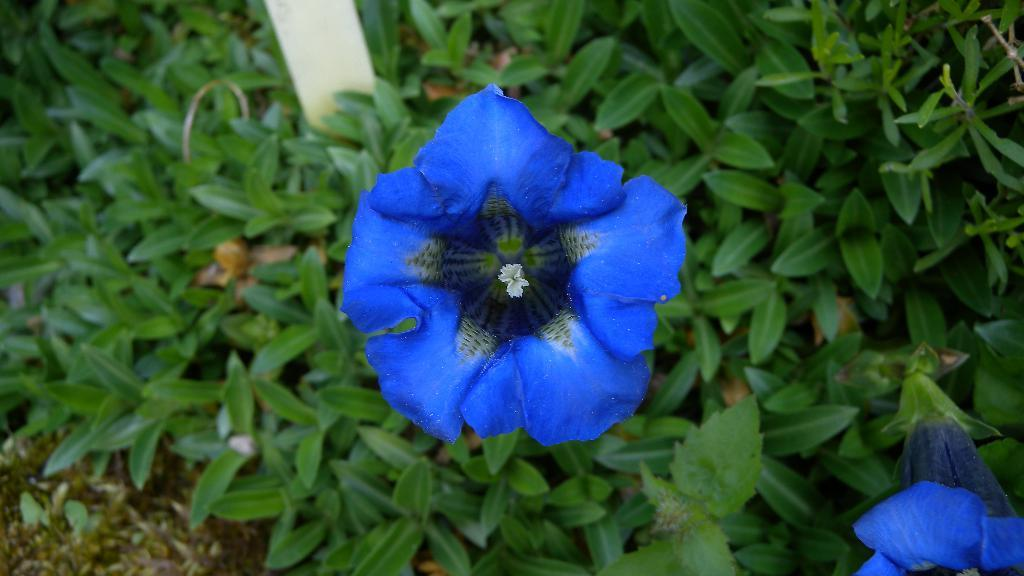What type of flower is in the image? There is a blue flower in the image. How is the flower described? The flower is described as beautiful. What other elements are visible in the image besides the flower? There are green leaves visible in the image. What type of transport system is depicted in the image? There is no transport system present in the image; it features a blue flower and green leaves. What is the current condition of the flower in the image? The provided facts do not give any information about the condition of the flower, so it cannot be determined from the image. 